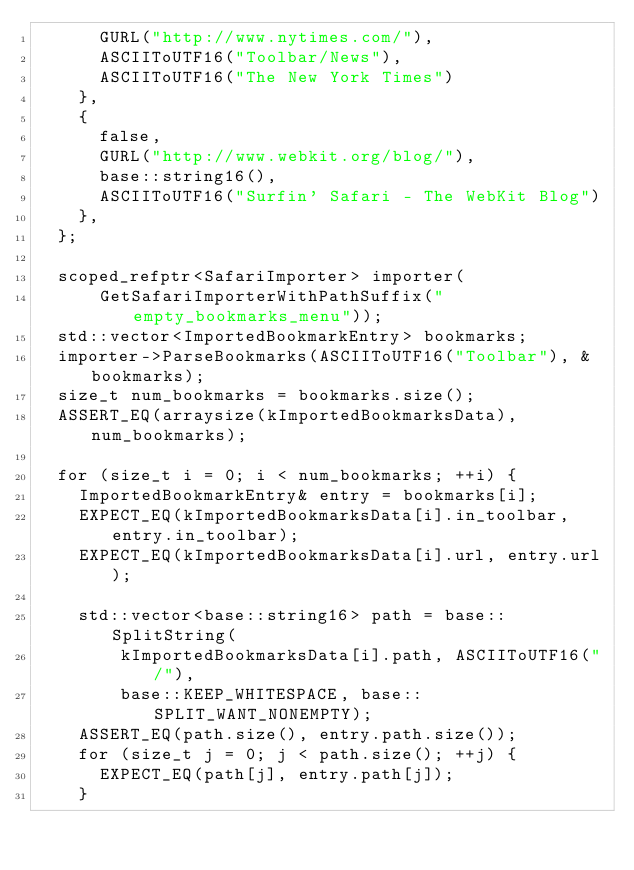Convert code to text. <code><loc_0><loc_0><loc_500><loc_500><_ObjectiveC_>      GURL("http://www.nytimes.com/"),
      ASCIIToUTF16("Toolbar/News"),
      ASCIIToUTF16("The New York Times")
    },
    {
      false,
      GURL("http://www.webkit.org/blog/"),
      base::string16(),
      ASCIIToUTF16("Surfin' Safari - The WebKit Blog")
    },
  };

  scoped_refptr<SafariImporter> importer(
      GetSafariImporterWithPathSuffix("empty_bookmarks_menu"));
  std::vector<ImportedBookmarkEntry> bookmarks;
  importer->ParseBookmarks(ASCIIToUTF16("Toolbar"), &bookmarks);
  size_t num_bookmarks = bookmarks.size();
  ASSERT_EQ(arraysize(kImportedBookmarksData), num_bookmarks);

  for (size_t i = 0; i < num_bookmarks; ++i) {
    ImportedBookmarkEntry& entry = bookmarks[i];
    EXPECT_EQ(kImportedBookmarksData[i].in_toolbar, entry.in_toolbar);
    EXPECT_EQ(kImportedBookmarksData[i].url, entry.url);

    std::vector<base::string16> path = base::SplitString(
        kImportedBookmarksData[i].path, ASCIIToUTF16("/"),
        base::KEEP_WHITESPACE, base::SPLIT_WANT_NONEMPTY);
    ASSERT_EQ(path.size(), entry.path.size());
    for (size_t j = 0; j < path.size(); ++j) {
      EXPECT_EQ(path[j], entry.path[j]);
    }
</code> 